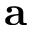<formula> <loc_0><loc_0><loc_500><loc_500>{ a }</formula> 